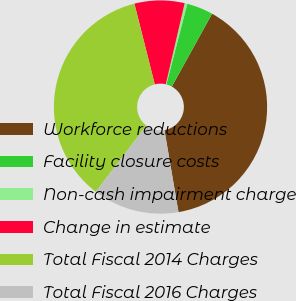Convert chart to OTSL. <chart><loc_0><loc_0><loc_500><loc_500><pie_chart><fcel>Workforce reductions<fcel>Facility closure costs<fcel>Non-cash impairment charge<fcel>Change in estimate<fcel>Total Fiscal 2014 Charges<fcel>Total Fiscal 2016 Charges<nl><fcel>39.26%<fcel>3.99%<fcel>0.41%<fcel>7.57%<fcel>35.68%<fcel>13.08%<nl></chart> 